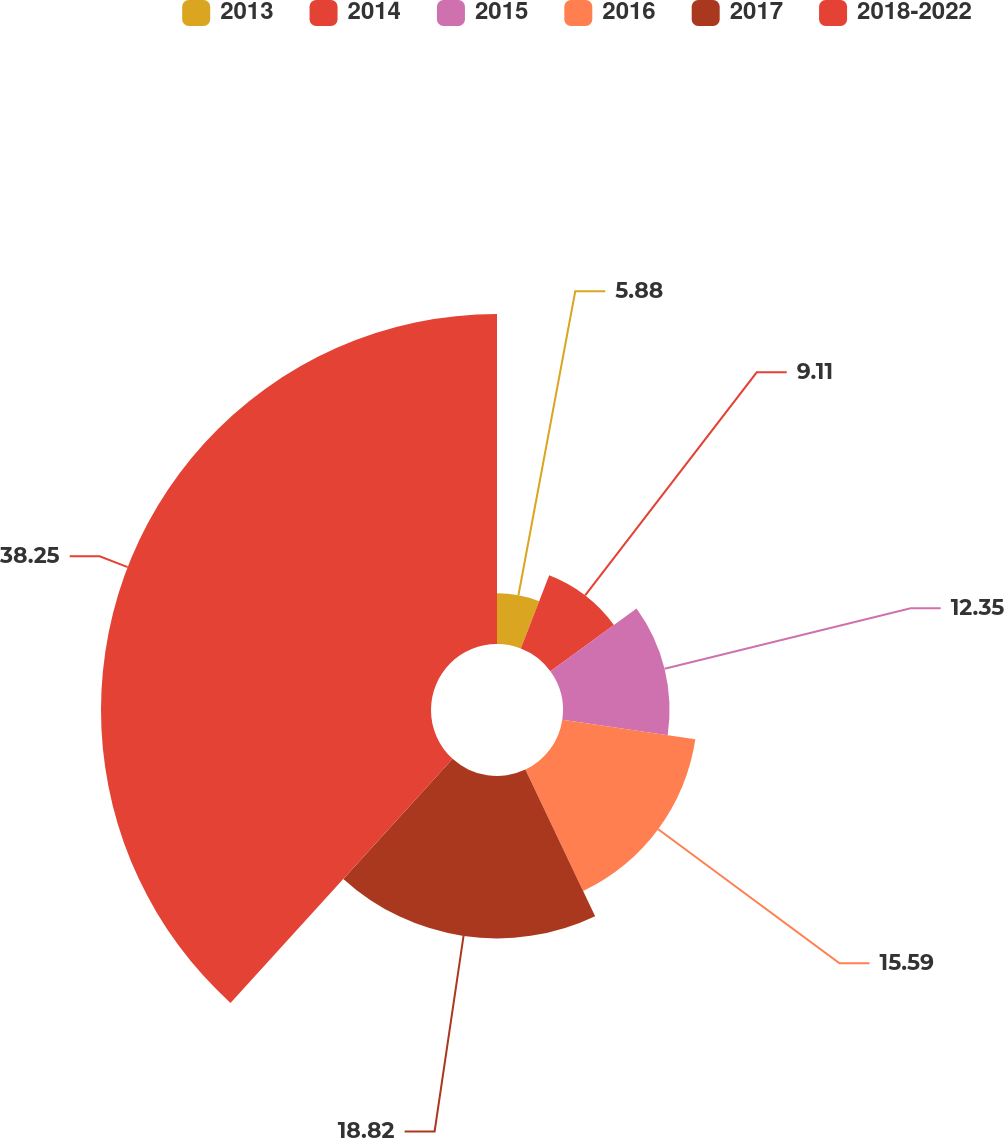Convert chart to OTSL. <chart><loc_0><loc_0><loc_500><loc_500><pie_chart><fcel>2013<fcel>2014<fcel>2015<fcel>2016<fcel>2017<fcel>2018-2022<nl><fcel>5.88%<fcel>9.11%<fcel>12.35%<fcel>15.59%<fcel>18.82%<fcel>38.25%<nl></chart> 